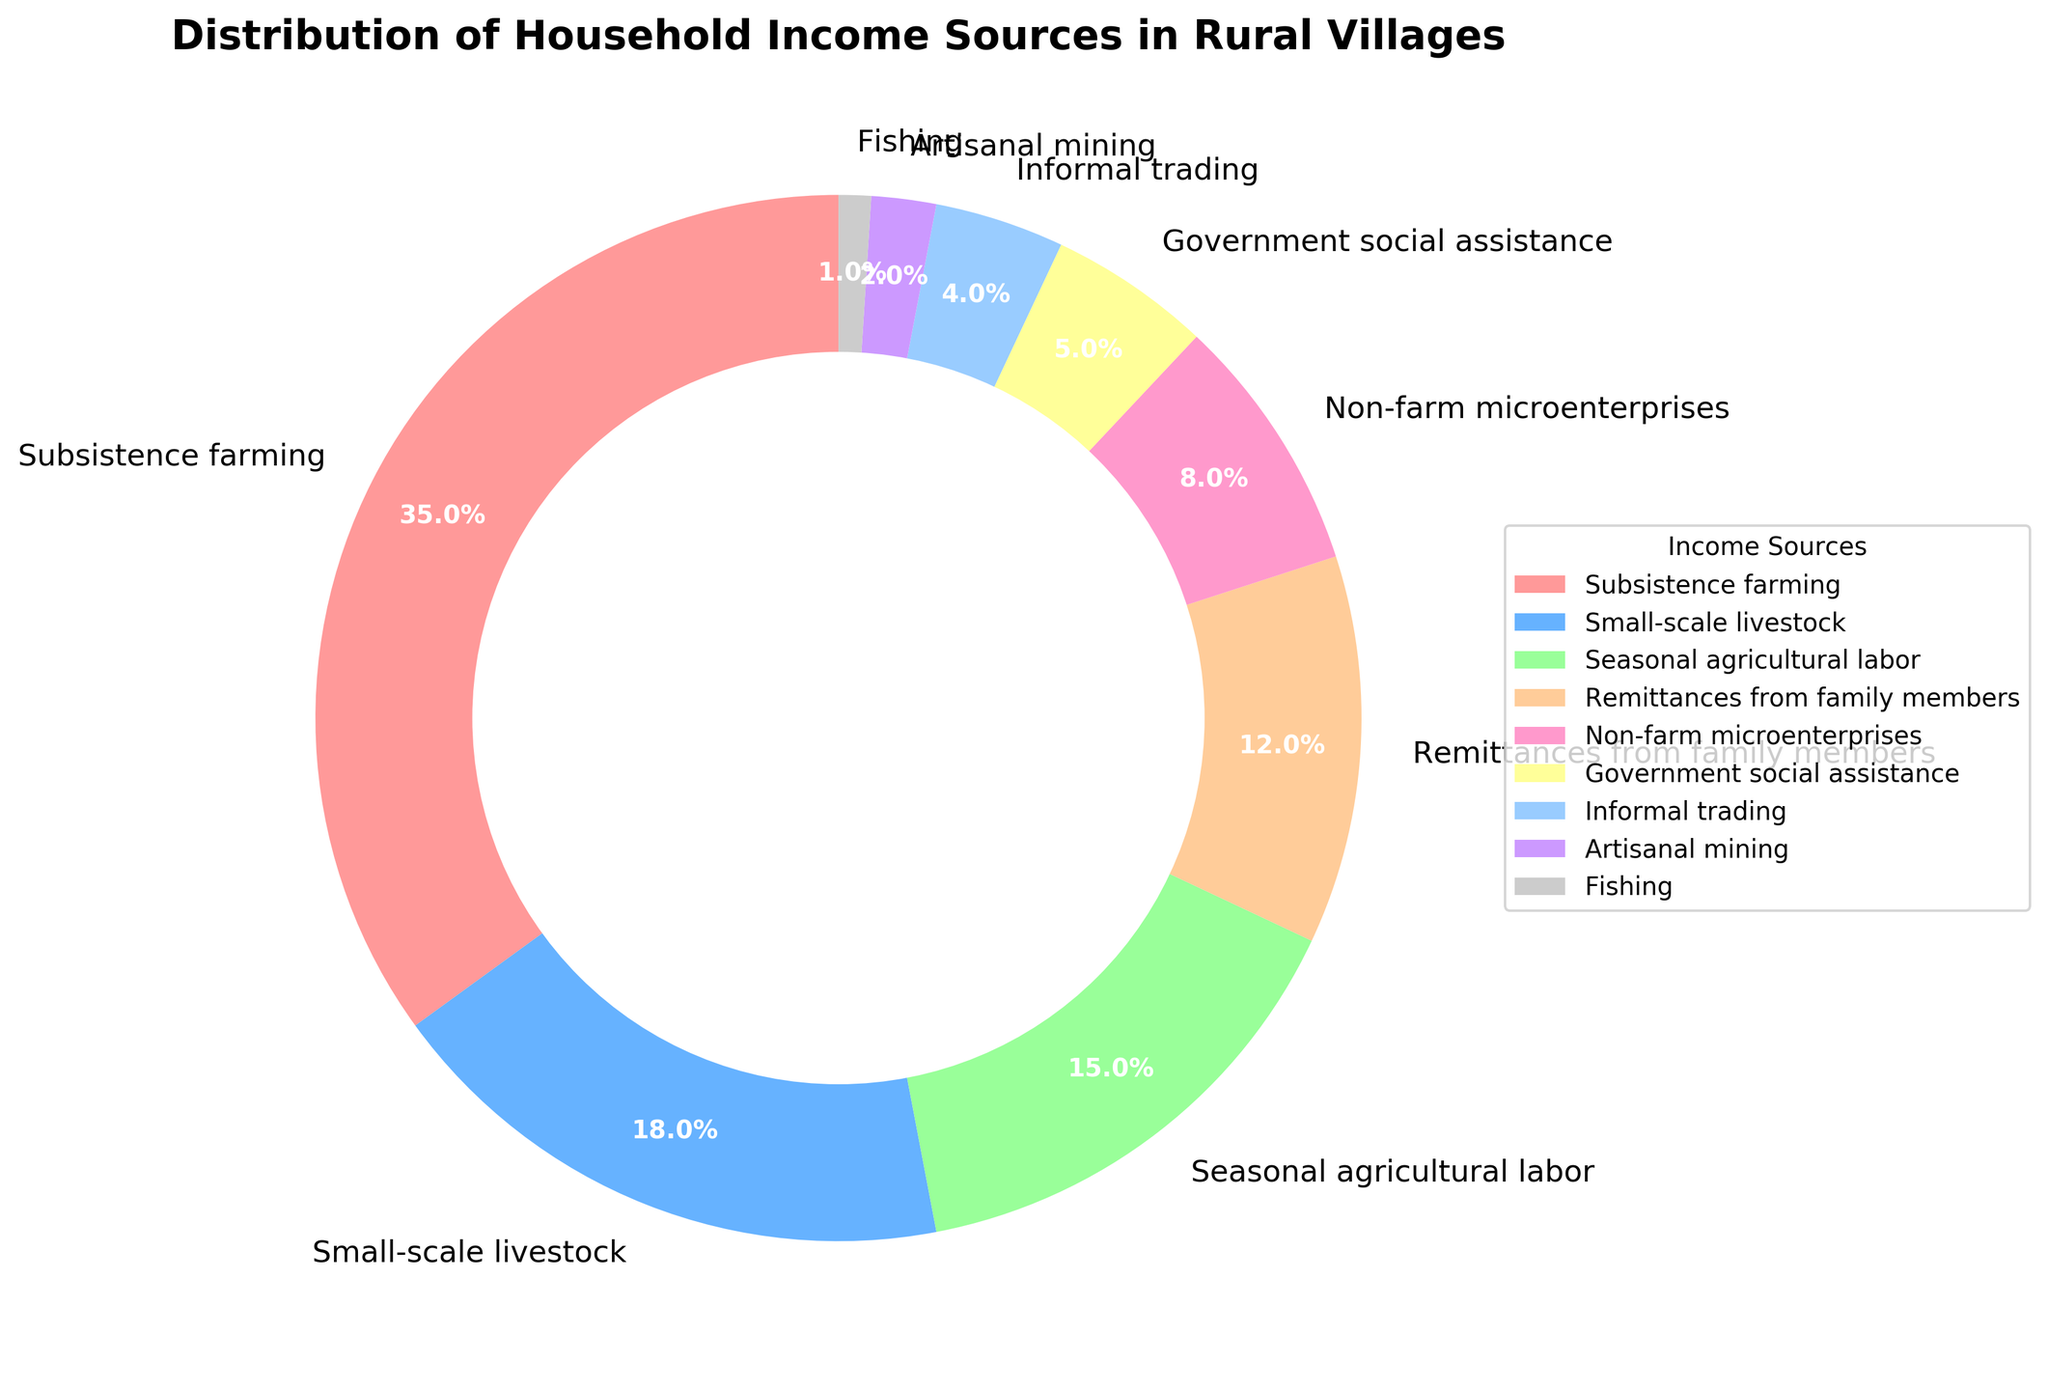What is the largest income source for households in the rural villages? The largest segment in the pie chart is labeled "Subsistence farming" and its percentage is the highest among all.
Answer: Subsistence farming Which income source contributes the least to household incomes? The smallest segment in the pie chart is labeled "Fishing" with the lowest percentage.
Answer: Fishing How much more does subsistence farming contribute to household income compared to government social assistance? Subsistence farming contributes 35%, and government social assistance contributes 5%. The difference is 35% - 5%.
Answer: 30% What is the combined percentage of households that rely on small-scale livestock and remittances from family members? Small-scale livestock contributes 18% and remittances from family members contribute 12%. The combined percentage is 18% + 12%.
Answer: 30% How do the contributions of seasonal agricultural labor and non-farm microenterprises compare? Seasonal agricultural labor contributes 15%, while non-farm microenterprises contribute 8%. Seasonal agricultural labor contributes more.
Answer: Seasonal agricultural labor What percentage of household income comes from income sources other than subsistence farming, small-scale livestock, and seasonal agricultural labor? Excluding subsistence farming (35%), small-scale livestock (18%), and seasonal agricultural labor (15%), the sum of the remaining sources is 100% - (35% + 18% + 15%) = 32%.
Answer: 32% Which three income sources together make up just over half of the household income? Subsistence farming (35%), small-scale livestock (18%), and seasonal agricultural labor (15%) together make up 35% + 18% + 15% = 68%.
Answer: Subsistence farming, small-scale livestock, seasonal agricultural labor Are remittances from family members a more significant income source than government social assistance? Remittances from family members contribute 12%, while government social assistance contributes 5%. Remittances from family members contribute more.
Answer: Yes What percentage difference is there between informal trading and artisanal mining as income sources? Informal trading contributes 4%, while artisanal mining contributes 2%. The percentage difference is 4% - 2%.
Answer: 2% What is the total percentage contribution of income sources that each account for less than 10%? Adding the percentages of non-farm microenterprises (8%), government social assistance (5%), informal trading (4%), artisanal mining (2%), and fishing (1%) gives 8% + 5% + 4% + 2% + 1% = 20%.
Answer: 20% 